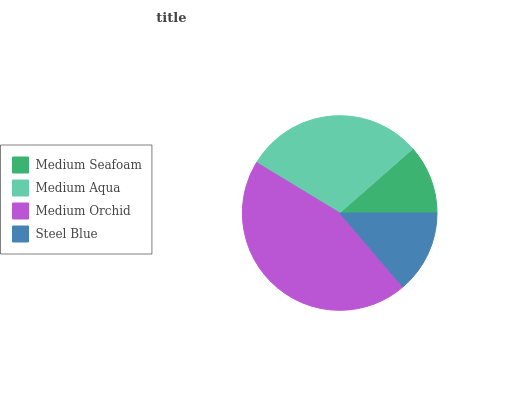Is Medium Seafoam the minimum?
Answer yes or no. Yes. Is Medium Orchid the maximum?
Answer yes or no. Yes. Is Medium Aqua the minimum?
Answer yes or no. No. Is Medium Aqua the maximum?
Answer yes or no. No. Is Medium Aqua greater than Medium Seafoam?
Answer yes or no. Yes. Is Medium Seafoam less than Medium Aqua?
Answer yes or no. Yes. Is Medium Seafoam greater than Medium Aqua?
Answer yes or no. No. Is Medium Aqua less than Medium Seafoam?
Answer yes or no. No. Is Medium Aqua the high median?
Answer yes or no. Yes. Is Steel Blue the low median?
Answer yes or no. Yes. Is Steel Blue the high median?
Answer yes or no. No. Is Medium Seafoam the low median?
Answer yes or no. No. 